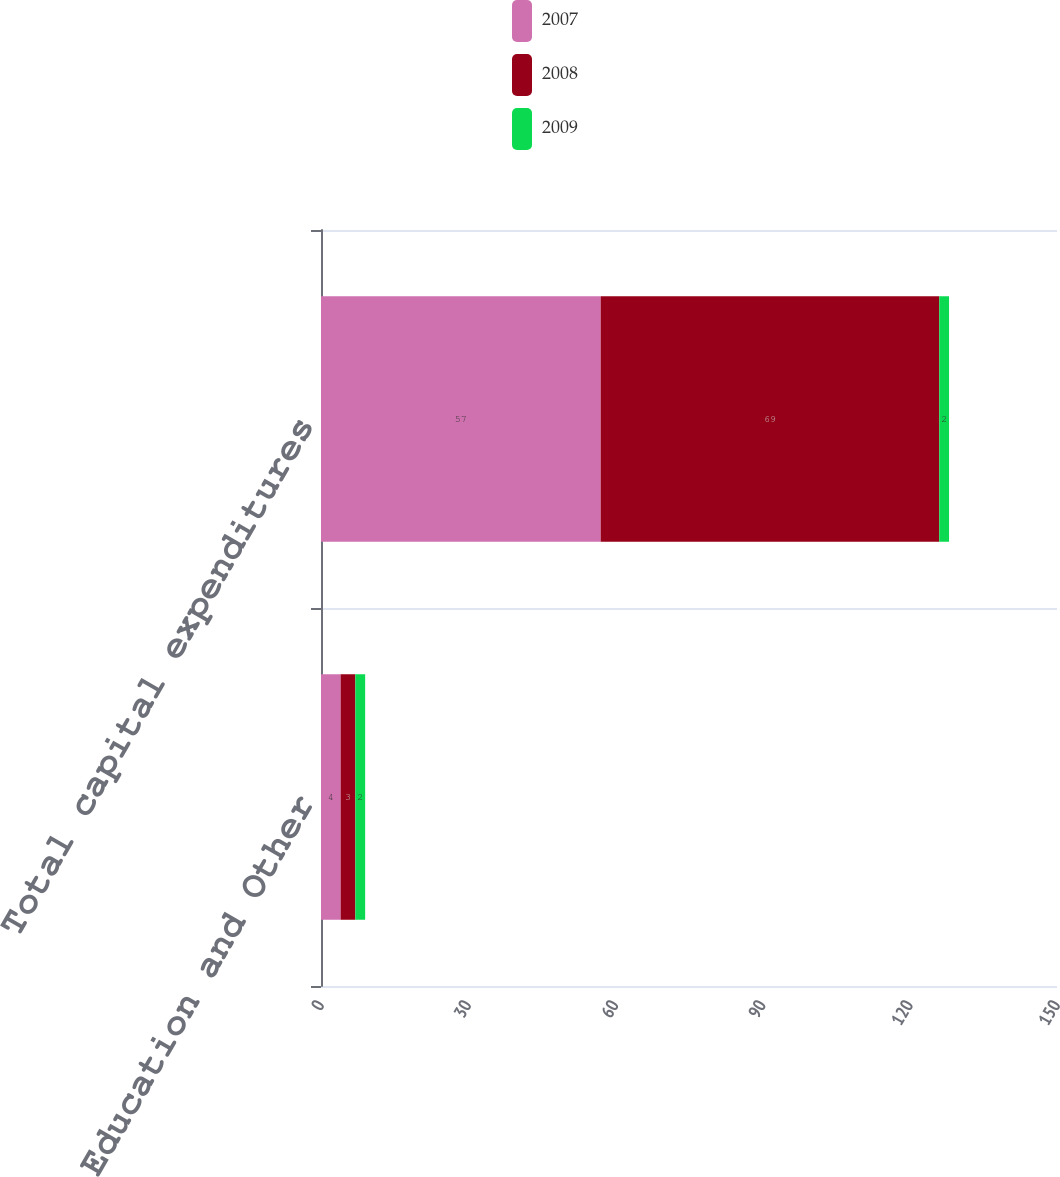Convert chart to OTSL. <chart><loc_0><loc_0><loc_500><loc_500><stacked_bar_chart><ecel><fcel>Commerce Education and Other<fcel>Total capital expenditures<nl><fcel>2007<fcel>4<fcel>57<nl><fcel>2008<fcel>3<fcel>69<nl><fcel>2009<fcel>2<fcel>2<nl></chart> 